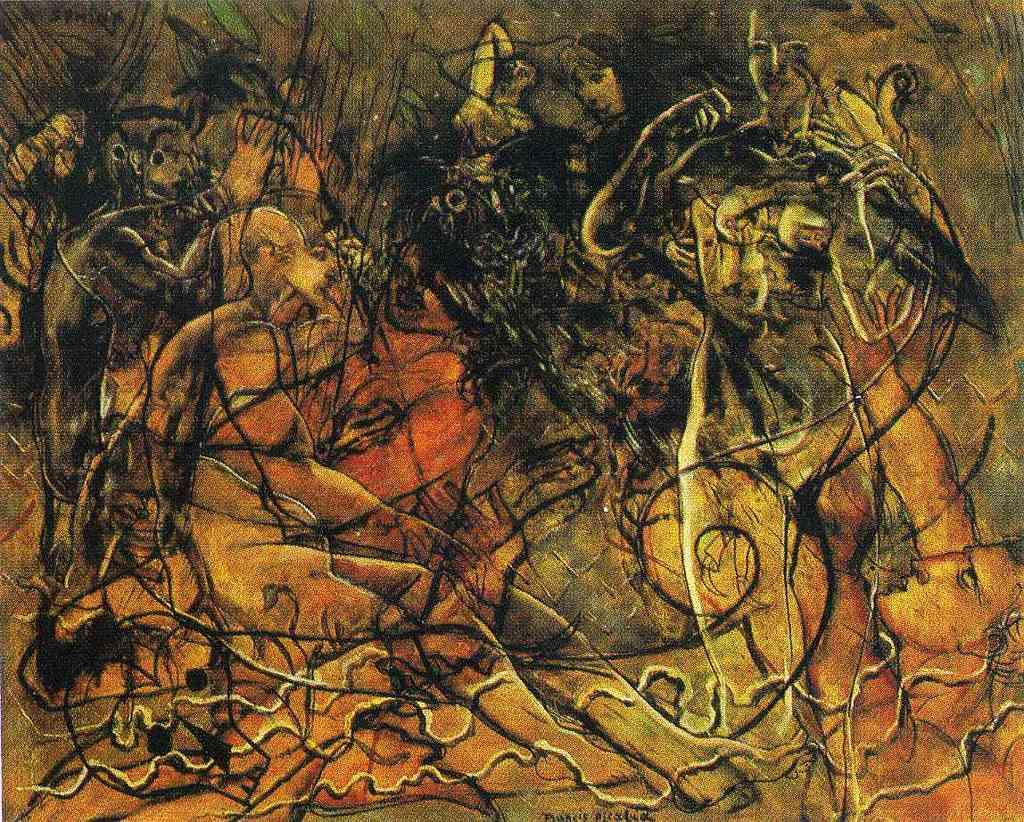What type of drawings can be seen in the image? There are drawings of people and trees in the image. Are there any other types of drawings or designs in the image? Yes, there are other designs present in the image. How many seeds can be seen in the image? There are no seeds present in the image; it contains drawings of people, trees, and other designs. What type of goose is depicted in the image? There is no goose present in the image; it contains drawings of people, trees, and other designs. 